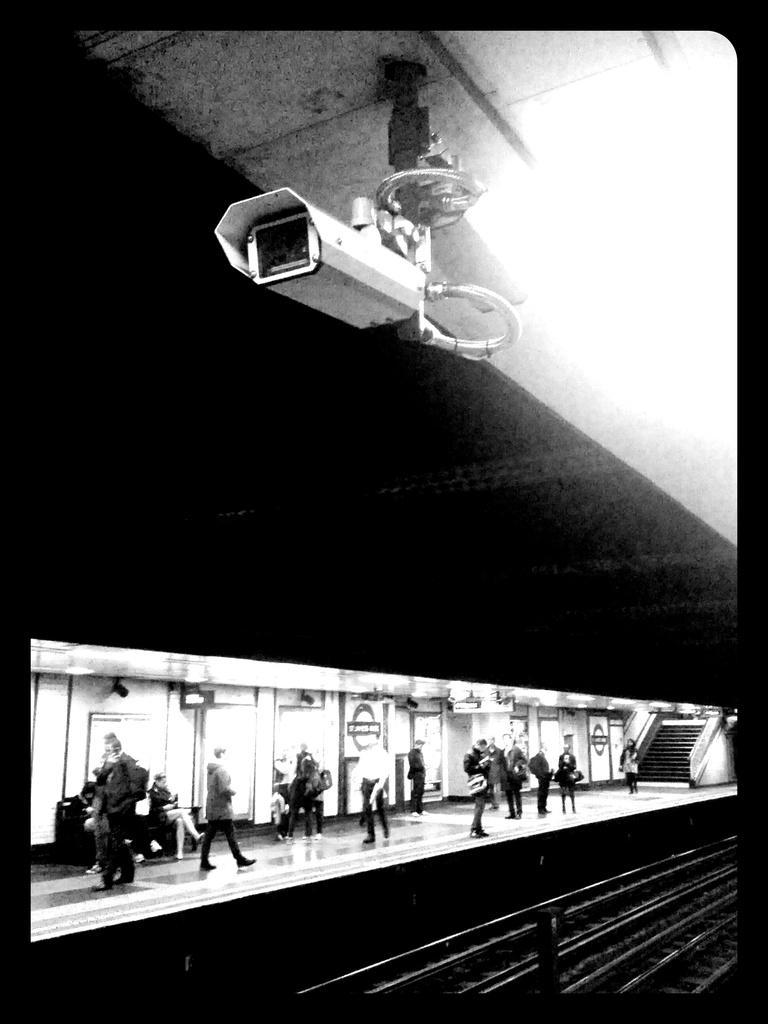Can you describe this image briefly? In this image we can see few persons on a platform. Behind the persons we can see the wall and the stairs. Beside the platform we can see the railway tracks. At the top there is a camera attached to the roof. 